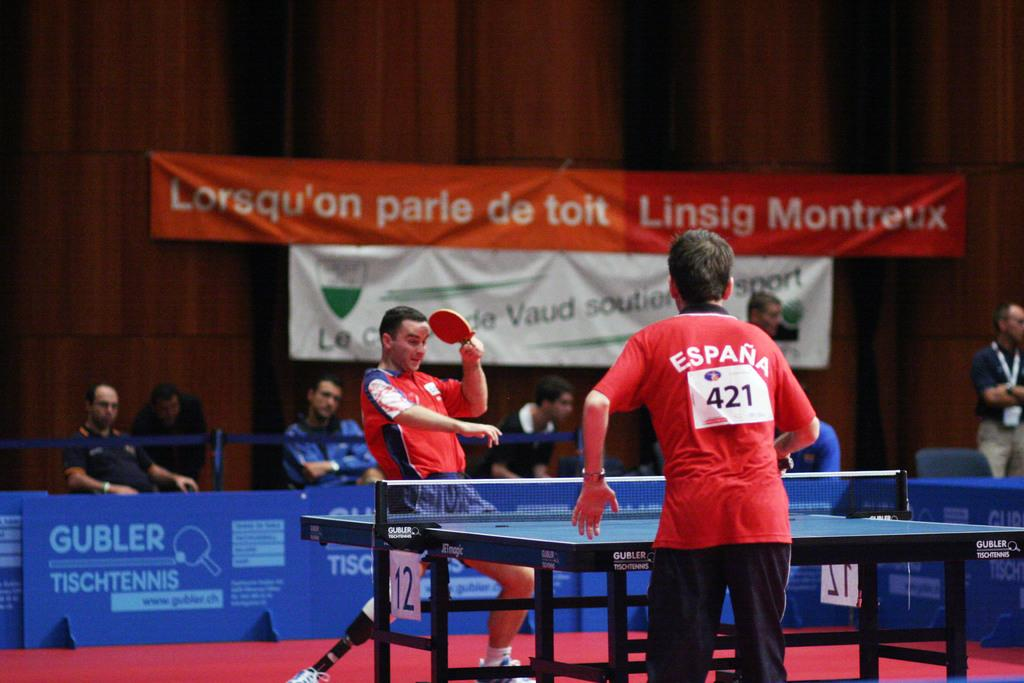<image>
Write a terse but informative summary of the picture. a person with the number 421 on their back 